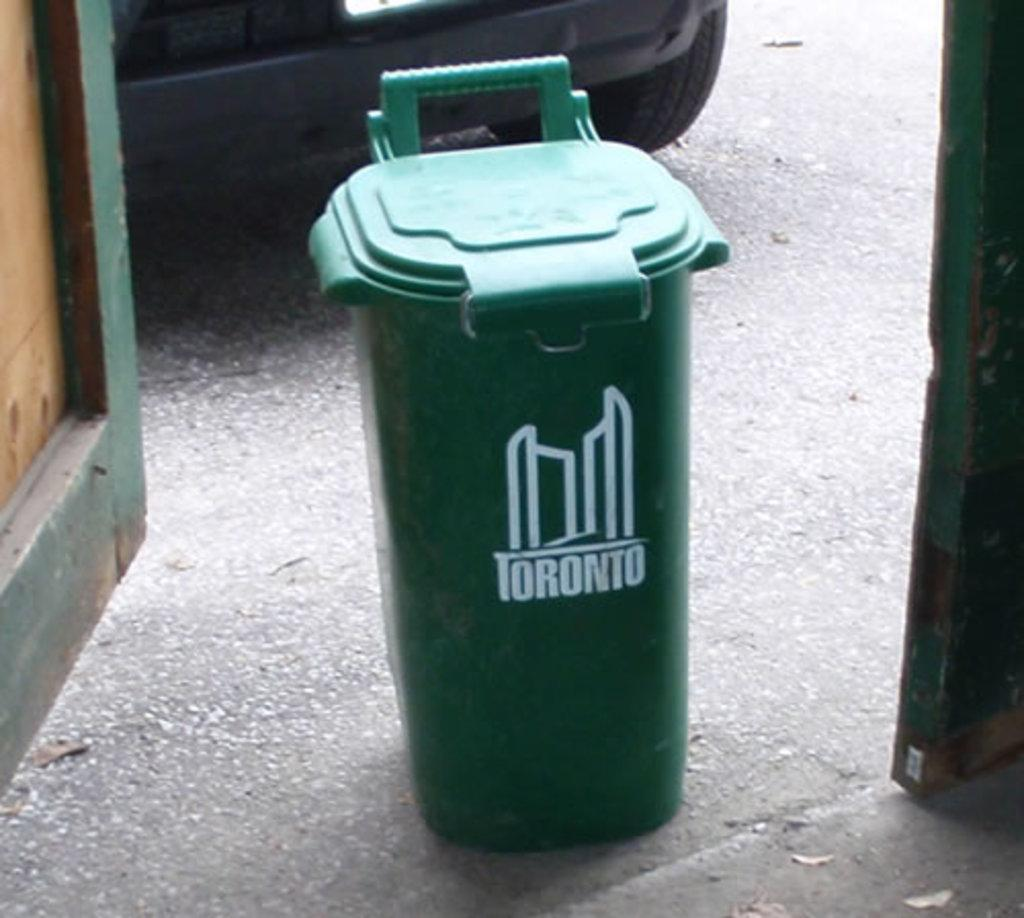<image>
Relay a brief, clear account of the picture shown. Green garbage can which says Toronto in white. 